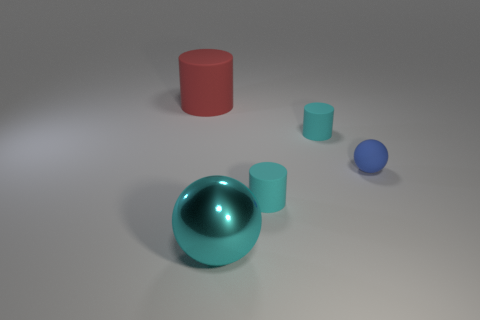There is a metal thing; is it the same color as the tiny cylinder in front of the blue rubber ball?
Your response must be concise. Yes. Is there a green rubber ball?
Give a very brief answer. No. The other object that is the same shape as the small blue matte object is what color?
Offer a terse response. Cyan. Does the tiny rubber object that is behind the rubber ball have the same color as the metallic thing?
Your answer should be very brief. Yes. Is the size of the cyan metallic sphere the same as the blue object?
Your answer should be compact. No. What is the shape of the blue thing that is made of the same material as the big red object?
Offer a terse response. Sphere. What number of other objects are there of the same shape as the metal object?
Your answer should be very brief. 1. What is the shape of the large object to the right of the object on the left side of the big thing that is in front of the large rubber cylinder?
Provide a succinct answer. Sphere. What number of cubes are either metal things or tiny blue things?
Your answer should be very brief. 0. Is there a tiny cyan rubber cylinder in front of the big thing that is right of the large rubber cylinder?
Offer a very short reply. No. 